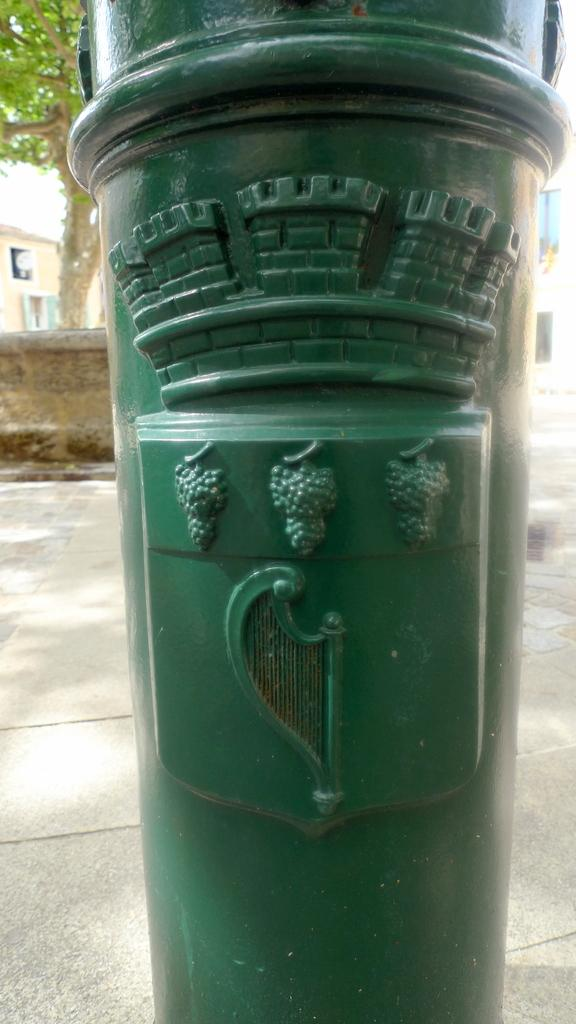What is the main object in the center of the image? There is a water pole in the center of the image. What is the color of the water pole? The water pole is green in color. What can be seen in the background of the image? There is a building, a tree, and a wall in the background of the image. What type of lace is used to decorate the water pole in the image? There is no lace present on the water pole in the image. What time of day is depicted in the image? The time of day cannot be determined from the image, as there are no specific clues or indicators present. 